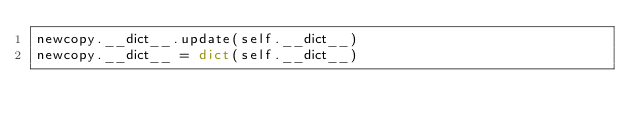<code> <loc_0><loc_0><loc_500><loc_500><_Python_>newcopy.__dict__.update(self.__dict__)
newcopy.__dict__ = dict(self.__dict__)
</code> 